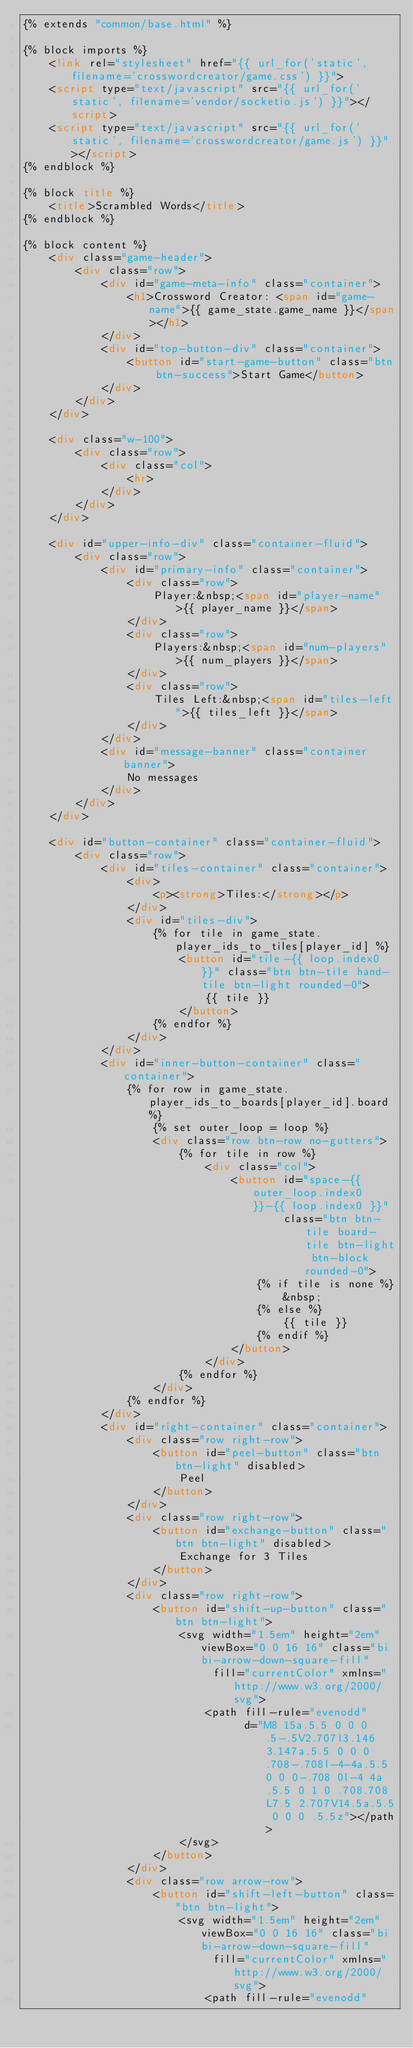Convert code to text. <code><loc_0><loc_0><loc_500><loc_500><_HTML_>{% extends "common/base.html" %}

{% block imports %}
    <link rel="stylesheet" href="{{ url_for('static', filename='crosswordcreator/game.css') }}">
    <script type="text/javascript" src="{{ url_for('static', filename='vendor/socketio.js') }}"></script>
    <script type="text/javascript" src="{{ url_for('static', filename='crosswordcreator/game.js') }}"></script>
{% endblock %}

{% block title %}
    <title>Scrambled Words</title>
{% endblock %}

{% block content %}
    <div class="game-header">
        <div class="row">
            <div id="game-meta-info" class="container">
                <h1>Crossword Creator: <span id="game-name">{{ game_state.game_name }}</span></h1>
            </div>
            <div id="top-button-div" class="container">
                <button id="start-game-button" class="btn btn-success">Start Game</button>
            </div>
        </div>
    </div>

    <div class="w-100">
        <div class="row">
            <div class="col">
                <hr>
            </div>
        </div>
    </div>

    <div id="upper-info-div" class="container-fluid">
        <div class="row">
            <div id="primary-info" class="container">
                <div class="row">
                    Player:&nbsp;<span id="player-name">{{ player_name }}</span>
                </div>
                <div class="row">
                    Players:&nbsp;<span id="num-players">{{ num_players }}</span>
                </div>
                <div class="row">
                    Tiles Left:&nbsp;<span id="tiles-left">{{ tiles_left }}</span>
                </div>
            </div>
            <div id="message-banner" class="container banner">
                No messages
            </div>
        </div>
    </div>

    <div id="button-container" class="container-fluid">
        <div class="row">
            <div id="tiles-container" class="container">
                <div>
                    <p><strong>Tiles:</strong></p>
                </div>
                <div id="tiles-div">
                    {% for tile in game_state.player_ids_to_tiles[player_id] %}
                        <button id="tile-{{ loop.index0 }}" class="btn btn-tile hand-tile btn-light rounded-0">
                            {{ tile }}
                        </button>
                    {% endfor %}
                </div>
            </div>
            <div id="inner-button-container" class="container">
                {% for row in game_state.player_ids_to_boards[player_id].board %}
                    {% set outer_loop = loop %}
                    <div class="row btn-row no-gutters">
                        {% for tile in row %}
                            <div class="col">
                                <button id="space-{{ outer_loop.index0 }}-{{ loop.index0 }}"
                                        class="btn btn-tile board-tile btn-light btn-block rounded-0">
                                    {% if tile is none %}
                                        &nbsp;
                                    {% else %}
                                        {{ tile }}
                                    {% endif %}
                                </button>
                            </div>
                        {% endfor %}
                    </div>
                {% endfor %}
            </div>
            <div id="right-container" class="container">
                <div class="row right-row">
                    <button id="peel-button" class="btn btn-light" disabled>
                        Peel
                    </button>
                </div>
                <div class="row right-row">
                    <button id="exchange-button" class="btn btn-light" disabled>
                        Exchange for 3 Tiles
                    </button>
                </div>
                <div class="row right-row">
                    <button id="shift-up-button" class="btn btn-light">
                        <svg width="1.5em" height="2em" viewBox="0 0 16 16" class="bi bi-arrow-down-square-fill"
                             fill="currentColor" xmlns="http://www.w3.org/2000/svg">
                            <path fill-rule="evenodd"
                                  d="M8 15a.5.5 0 0 0 .5-.5V2.707l3.146 3.147a.5.5 0 0 0 .708-.708l-4-4a.5.5 0 0 0-.708 0l-4 4a.5.5 0 1 0 .708.708L7.5 2.707V14.5a.5.5 0 0 0 .5.5z"></path>
                        </svg>
                    </button>
                </div>
                <div class="row arrow-row">
                    <button id="shift-left-button" class="btn btn-light">
                        <svg width="1.5em" height="2em" viewBox="0 0 16 16" class="bi bi-arrow-down-square-fill"
                             fill="currentColor" xmlns="http://www.w3.org/2000/svg">
                            <path fill-rule="evenodd"</code> 